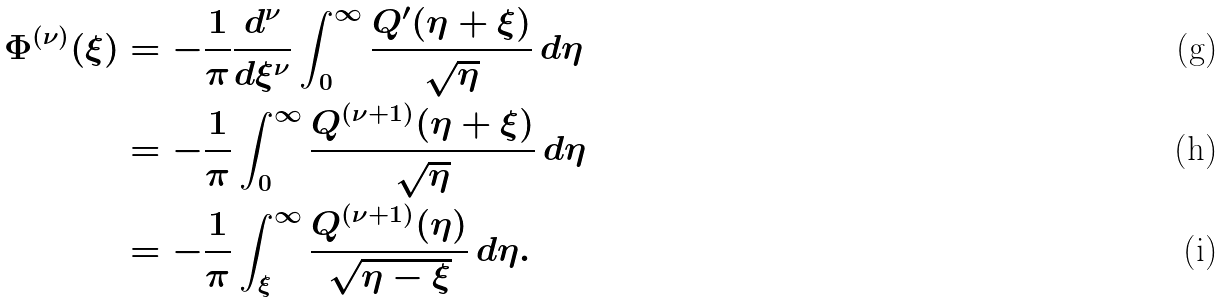Convert formula to latex. <formula><loc_0><loc_0><loc_500><loc_500>\Phi ^ { ( \nu ) } ( \xi ) & = - \frac { 1 } { \pi } \frac { d ^ { \nu } } { d \xi ^ { \nu } } \int _ { 0 } ^ { \infty } \frac { Q ^ { \prime } ( \eta + \xi ) } { \sqrt { \eta } } \, d \eta \\ & = - \frac { 1 } { \pi } \int _ { 0 } ^ { \infty } \frac { Q ^ { ( \nu + 1 ) } ( \eta + \xi ) } { \sqrt { \eta } } \, d \eta \\ & = - \frac { 1 } { \pi } \int _ { \xi } ^ { \infty } \frac { Q ^ { ( \nu + 1 ) } ( \eta ) } { \sqrt { \eta - \xi } } \, d \eta .</formula> 